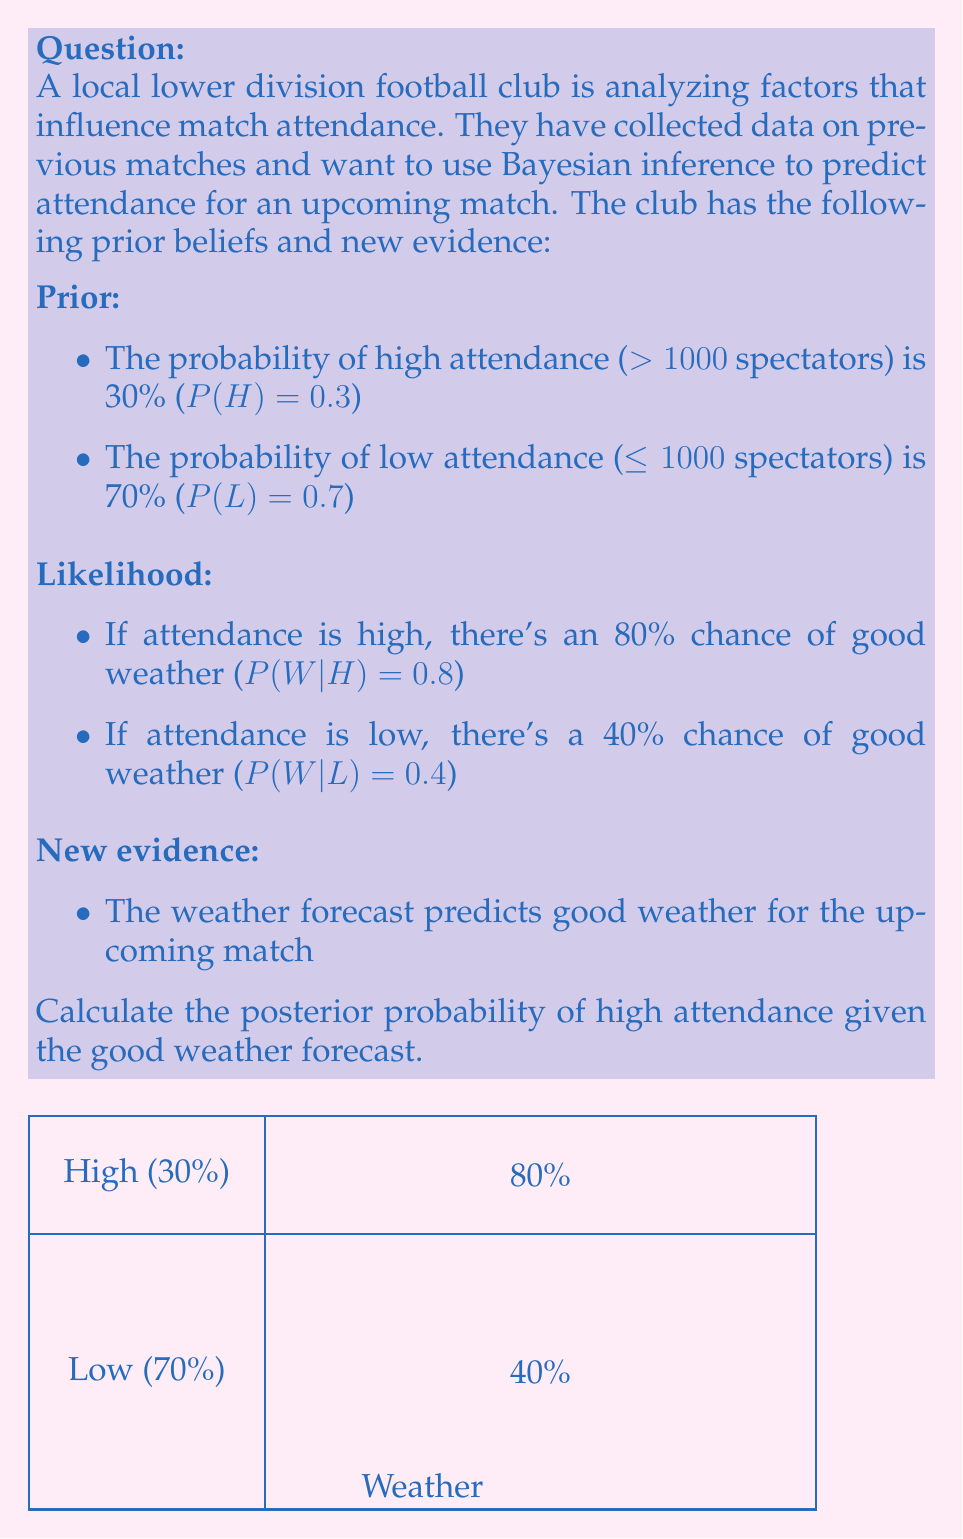Give your solution to this math problem. To solve this problem using Bayesian inference, we'll follow these steps:

1. Define the events:
   H: High attendance (>1000 spectators)
   L: Low attendance (≤1000 spectators)
   W: Good weather

2. Given information:
   P(H) = 0.3 (prior probability of high attendance)
   P(L) = 0.7 (prior probability of low attendance)
   P(W|H) = 0.8 (likelihood of good weather given high attendance)
   P(W|L) = 0.4 (likelihood of good weather given low attendance)

3. We want to calculate P(H|W) using Bayes' theorem:

   $$P(H|W) = \frac{P(W|H) \cdot P(H)}{P(W)}$$

4. Calculate P(W) using the law of total probability:
   $$P(W) = P(W|H) \cdot P(H) + P(W|L) \cdot P(L)$$
   $$P(W) = 0.8 \cdot 0.3 + 0.4 \cdot 0.7 = 0.24 + 0.28 = 0.52$$

5. Now we can apply Bayes' theorem:
   $$P(H|W) = \frac{P(W|H) \cdot P(H)}{P(W)} = \frac{0.8 \cdot 0.3}{0.52} = \frac{0.24}{0.52} \approx 0.4615$$

6. Convert to a percentage:
   0.4615 * 100 ≈ 46.15%

Therefore, given the good weather forecast, the posterior probability of high attendance is approximately 46.15%.
Answer: 46.15% 